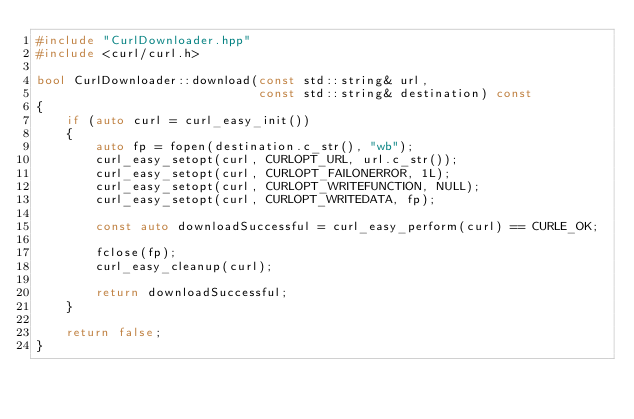<code> <loc_0><loc_0><loc_500><loc_500><_C++_>#include "CurlDownloader.hpp"
#include <curl/curl.h>

bool CurlDownloader::download(const std::string& url,
                              const std::string& destination) const
{
    if (auto curl = curl_easy_init())
    {
        auto fp = fopen(destination.c_str(), "wb");
        curl_easy_setopt(curl, CURLOPT_URL, url.c_str());
        curl_easy_setopt(curl, CURLOPT_FAILONERROR, 1L);
        curl_easy_setopt(curl, CURLOPT_WRITEFUNCTION, NULL);
        curl_easy_setopt(curl, CURLOPT_WRITEDATA, fp);

        const auto downloadSuccessful = curl_easy_perform(curl) == CURLE_OK;

        fclose(fp);
        curl_easy_cleanup(curl);

        return downloadSuccessful;
    }

    return false;
}
</code> 